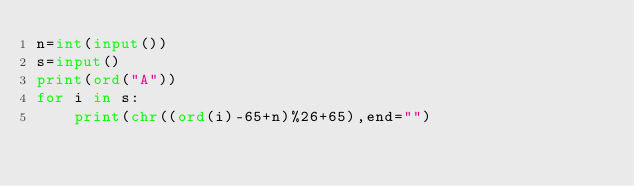Convert code to text. <code><loc_0><loc_0><loc_500><loc_500><_Python_>n=int(input())
s=input()
print(ord("A"))
for i in s:
    print(chr((ord(i)-65+n)%26+65),end="")
</code> 